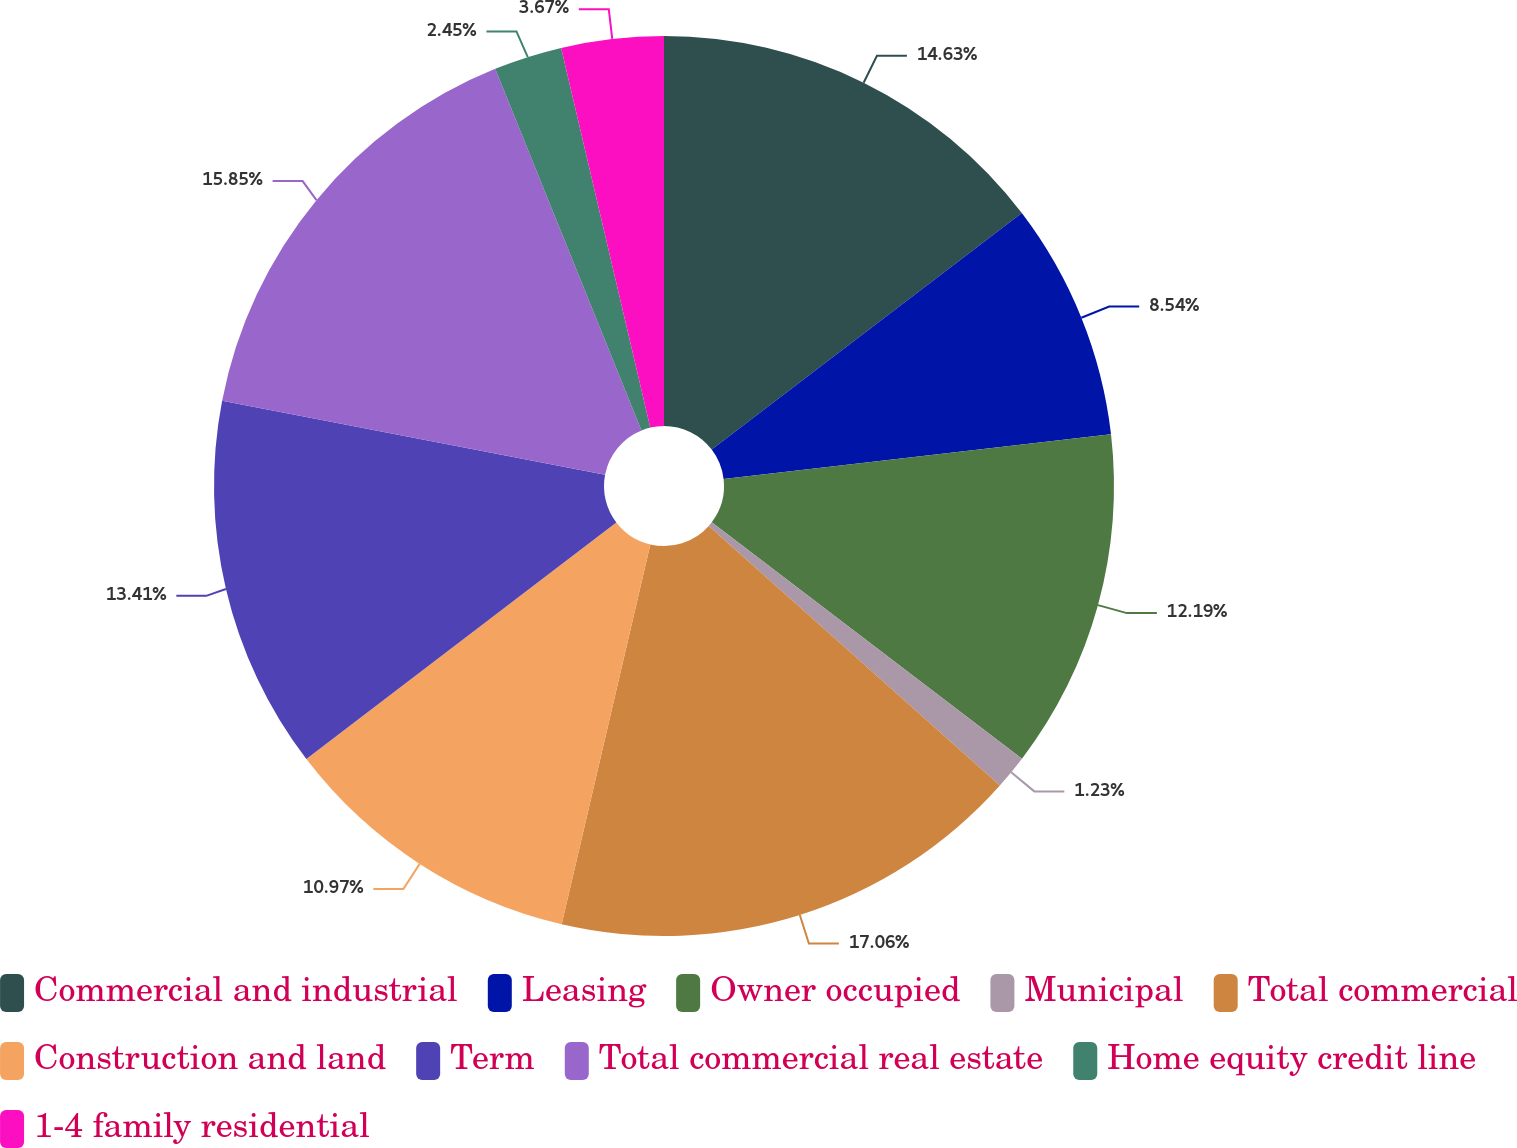Convert chart. <chart><loc_0><loc_0><loc_500><loc_500><pie_chart><fcel>Commercial and industrial<fcel>Leasing<fcel>Owner occupied<fcel>Municipal<fcel>Total commercial<fcel>Construction and land<fcel>Term<fcel>Total commercial real estate<fcel>Home equity credit line<fcel>1-4 family residential<nl><fcel>14.63%<fcel>8.54%<fcel>12.19%<fcel>1.23%<fcel>17.06%<fcel>10.97%<fcel>13.41%<fcel>15.85%<fcel>2.45%<fcel>3.67%<nl></chart> 